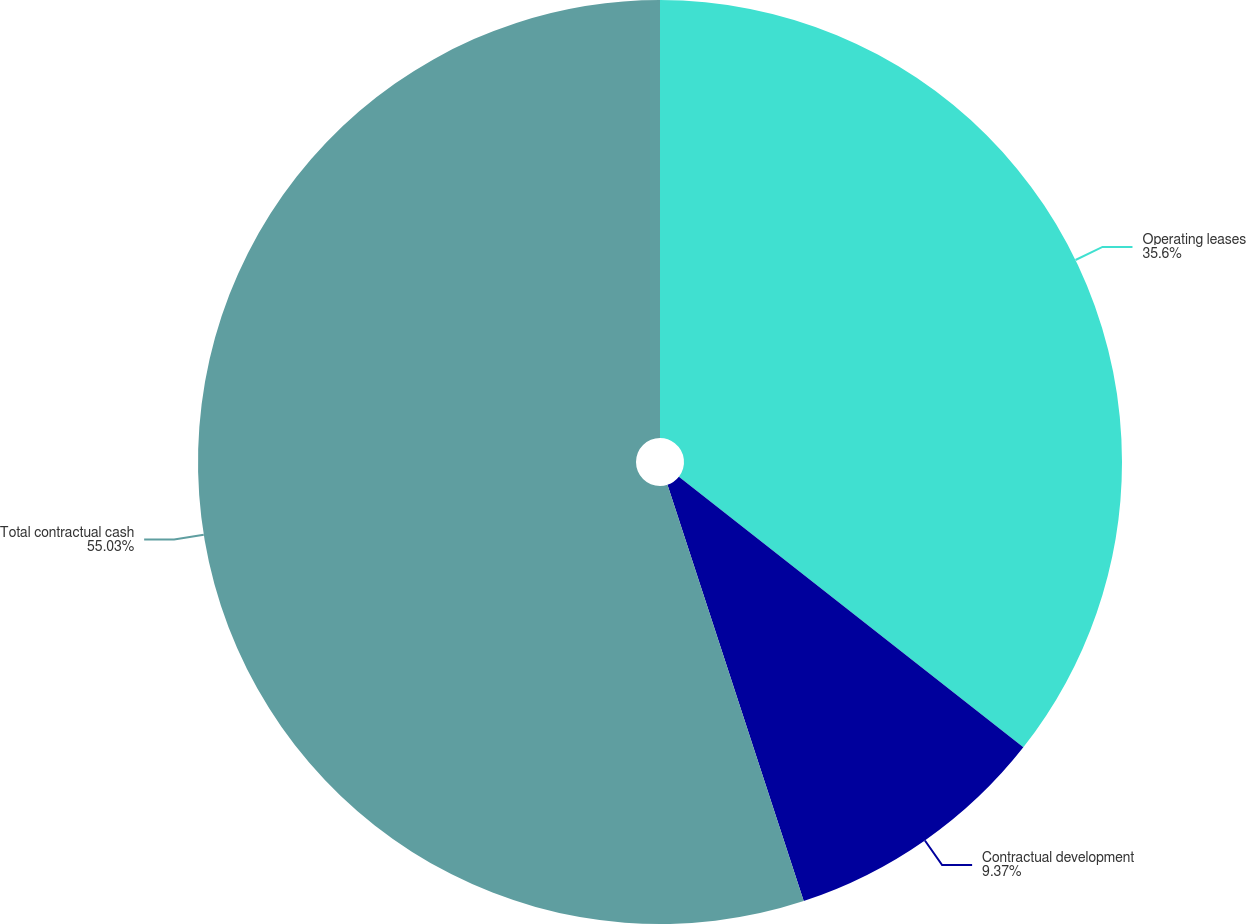<chart> <loc_0><loc_0><loc_500><loc_500><pie_chart><fcel>Operating leases<fcel>Contractual development<fcel>Total contractual cash<nl><fcel>35.6%<fcel>9.37%<fcel>55.04%<nl></chart> 